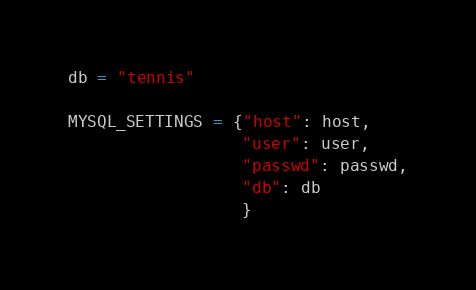<code> <loc_0><loc_0><loc_500><loc_500><_Python_>db = "tennis"

MYSQL_SETTINGS = {"host": host,
                  "user": user,
                  "passwd": passwd,
                  "db": db
                  }</code> 